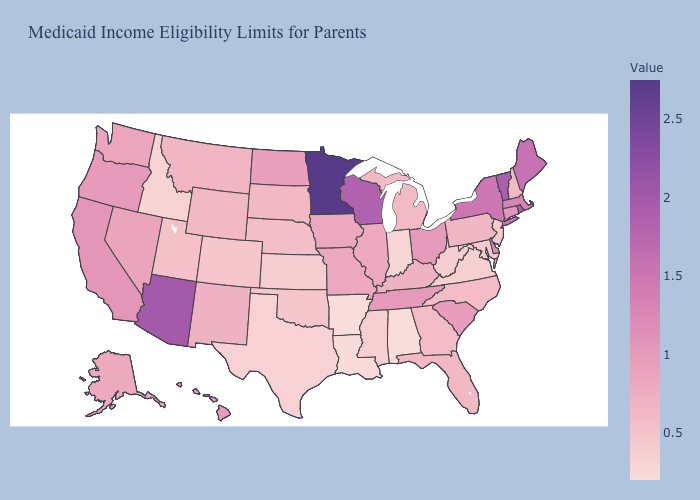Does Oklahoma have the highest value in the USA?
Concise answer only. No. Which states have the highest value in the USA?
Be succinct. Minnesota. Does New York have a higher value than Minnesota?
Be succinct. No. Does Michigan have the highest value in the MidWest?
Quick response, please. No. Which states have the lowest value in the Northeast?
Keep it brief. New Jersey. Does Arkansas have the lowest value in the USA?
Be succinct. Yes. 